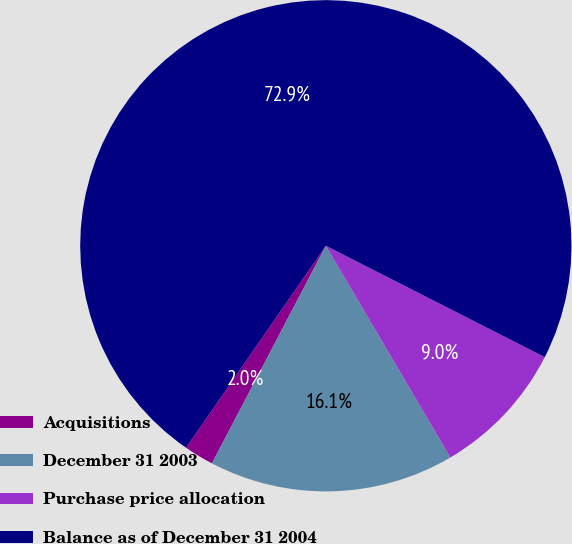Convert chart to OTSL. <chart><loc_0><loc_0><loc_500><loc_500><pie_chart><fcel>Acquisitions<fcel>December 31 2003<fcel>Purchase price allocation<fcel>Balance as of December 31 2004<nl><fcel>1.96%<fcel>16.14%<fcel>9.05%<fcel>72.86%<nl></chart> 